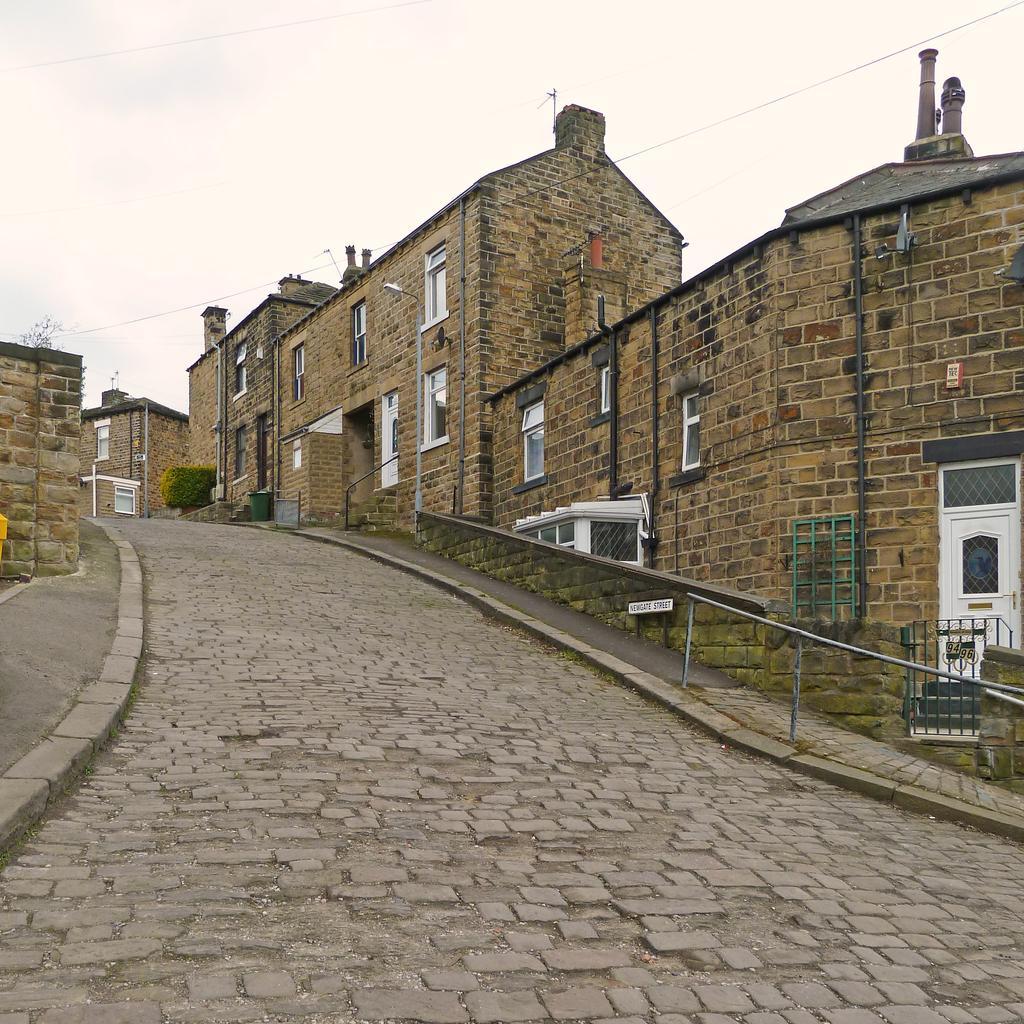Could you give a brief overview of what you see in this image? In the image we can see buildings made up of stones and these are the windows of the building. Here we can see the door, fence, stairs, footpath, plant, electric wires and the cloudy sky. 